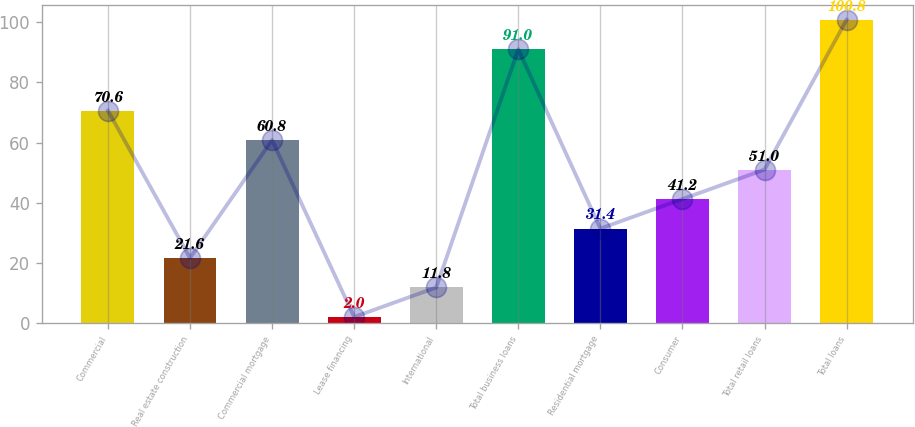<chart> <loc_0><loc_0><loc_500><loc_500><bar_chart><fcel>Commercial<fcel>Real estate construction<fcel>Commercial mortgage<fcel>Lease financing<fcel>International<fcel>Total business loans<fcel>Residential mortgage<fcel>Consumer<fcel>Total retail loans<fcel>Total loans<nl><fcel>70.6<fcel>21.6<fcel>60.8<fcel>2<fcel>11.8<fcel>91<fcel>31.4<fcel>41.2<fcel>51<fcel>100.8<nl></chart> 